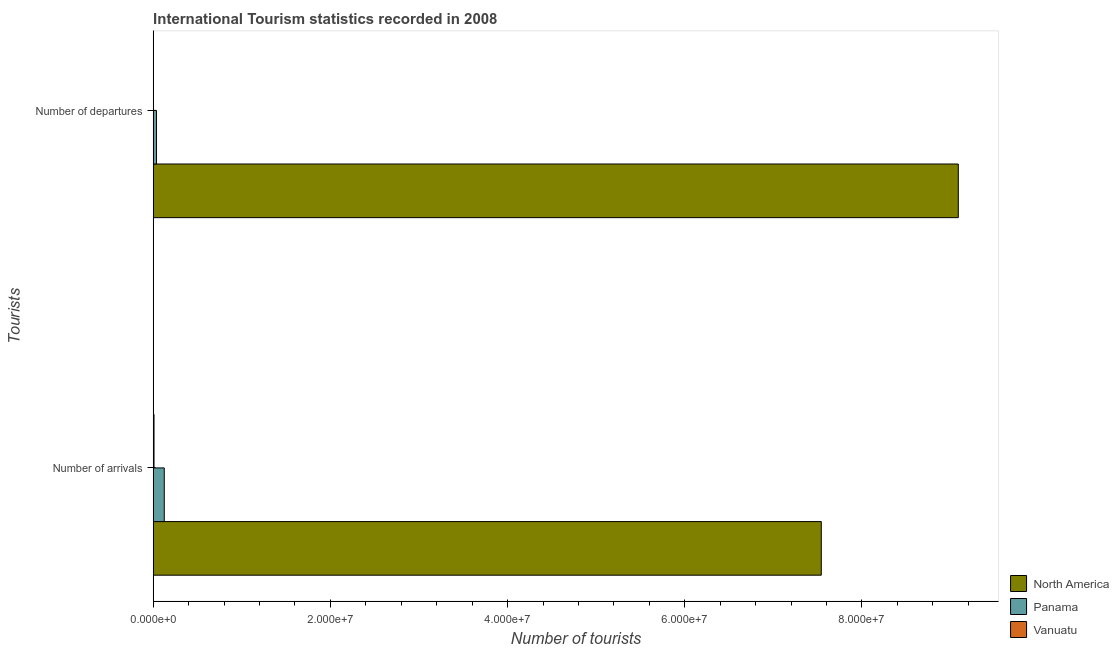How many groups of bars are there?
Offer a very short reply. 2. Are the number of bars per tick equal to the number of legend labels?
Offer a very short reply. Yes. What is the label of the 2nd group of bars from the top?
Give a very brief answer. Number of arrivals. What is the number of tourist departures in Vanuatu?
Make the answer very short. 1.90e+04. Across all countries, what is the maximum number of tourist arrivals?
Offer a terse response. 7.54e+07. Across all countries, what is the minimum number of tourist arrivals?
Your response must be concise. 9.10e+04. In which country was the number of tourist departures maximum?
Provide a short and direct response. North America. In which country was the number of tourist departures minimum?
Your answer should be very brief. Vanuatu. What is the total number of tourist arrivals in the graph?
Ensure brevity in your answer.  7.68e+07. What is the difference between the number of tourist departures in Panama and that in North America?
Your response must be concise. -9.05e+07. What is the difference between the number of tourist arrivals in Panama and the number of tourist departures in North America?
Ensure brevity in your answer.  -8.96e+07. What is the average number of tourist departures per country?
Your answer should be very brief. 3.04e+07. What is the difference between the number of tourist departures and number of tourist arrivals in Vanuatu?
Make the answer very short. -7.20e+04. In how many countries, is the number of tourist arrivals greater than 56000000 ?
Your answer should be compact. 1. What is the ratio of the number of tourist departures in North America to that in Panama?
Give a very brief answer. 246.28. In how many countries, is the number of tourist arrivals greater than the average number of tourist arrivals taken over all countries?
Provide a short and direct response. 1. What does the 3rd bar from the bottom in Number of departures represents?
Give a very brief answer. Vanuatu. How many bars are there?
Give a very brief answer. 6. Are all the bars in the graph horizontal?
Keep it short and to the point. Yes. How many countries are there in the graph?
Your answer should be compact. 3. Are the values on the major ticks of X-axis written in scientific E-notation?
Give a very brief answer. Yes. Does the graph contain grids?
Offer a very short reply. No. Where does the legend appear in the graph?
Provide a short and direct response. Bottom right. How many legend labels are there?
Make the answer very short. 3. How are the legend labels stacked?
Provide a succinct answer. Vertical. What is the title of the graph?
Provide a short and direct response. International Tourism statistics recorded in 2008. Does "Arab World" appear as one of the legend labels in the graph?
Provide a short and direct response. No. What is the label or title of the X-axis?
Offer a very short reply. Number of tourists. What is the label or title of the Y-axis?
Provide a succinct answer. Tourists. What is the Number of tourists in North America in Number of arrivals?
Offer a terse response. 7.54e+07. What is the Number of tourists of Panama in Number of arrivals?
Make the answer very short. 1.25e+06. What is the Number of tourists in Vanuatu in Number of arrivals?
Make the answer very short. 9.10e+04. What is the Number of tourists of North America in Number of departures?
Keep it short and to the point. 9.09e+07. What is the Number of tourists of Panama in Number of departures?
Make the answer very short. 3.69e+05. What is the Number of tourists of Vanuatu in Number of departures?
Give a very brief answer. 1.90e+04. Across all Tourists, what is the maximum Number of tourists in North America?
Offer a very short reply. 9.09e+07. Across all Tourists, what is the maximum Number of tourists of Panama?
Ensure brevity in your answer.  1.25e+06. Across all Tourists, what is the maximum Number of tourists of Vanuatu?
Ensure brevity in your answer.  9.10e+04. Across all Tourists, what is the minimum Number of tourists of North America?
Make the answer very short. 7.54e+07. Across all Tourists, what is the minimum Number of tourists of Panama?
Your answer should be very brief. 3.69e+05. Across all Tourists, what is the minimum Number of tourists of Vanuatu?
Your answer should be compact. 1.90e+04. What is the total Number of tourists of North America in the graph?
Your answer should be very brief. 1.66e+08. What is the total Number of tourists in Panama in the graph?
Provide a short and direct response. 1.62e+06. What is the total Number of tourists in Vanuatu in the graph?
Provide a short and direct response. 1.10e+05. What is the difference between the Number of tourists in North America in Number of arrivals and that in Number of departures?
Offer a terse response. -1.55e+07. What is the difference between the Number of tourists of Panama in Number of arrivals and that in Number of departures?
Offer a very short reply. 8.78e+05. What is the difference between the Number of tourists of Vanuatu in Number of arrivals and that in Number of departures?
Provide a succinct answer. 7.20e+04. What is the difference between the Number of tourists of North America in Number of arrivals and the Number of tourists of Panama in Number of departures?
Your answer should be very brief. 7.50e+07. What is the difference between the Number of tourists in North America in Number of arrivals and the Number of tourists in Vanuatu in Number of departures?
Your answer should be very brief. 7.54e+07. What is the difference between the Number of tourists in Panama in Number of arrivals and the Number of tourists in Vanuatu in Number of departures?
Offer a terse response. 1.23e+06. What is the average Number of tourists of North America per Tourists?
Your response must be concise. 8.31e+07. What is the average Number of tourists in Panama per Tourists?
Keep it short and to the point. 8.08e+05. What is the average Number of tourists of Vanuatu per Tourists?
Make the answer very short. 5.50e+04. What is the difference between the Number of tourists in North America and Number of tourists in Panama in Number of arrivals?
Give a very brief answer. 7.42e+07. What is the difference between the Number of tourists of North America and Number of tourists of Vanuatu in Number of arrivals?
Give a very brief answer. 7.53e+07. What is the difference between the Number of tourists of Panama and Number of tourists of Vanuatu in Number of arrivals?
Give a very brief answer. 1.16e+06. What is the difference between the Number of tourists of North America and Number of tourists of Panama in Number of departures?
Your answer should be very brief. 9.05e+07. What is the difference between the Number of tourists of North America and Number of tourists of Vanuatu in Number of departures?
Your answer should be compact. 9.09e+07. What is the difference between the Number of tourists of Panama and Number of tourists of Vanuatu in Number of departures?
Make the answer very short. 3.50e+05. What is the ratio of the Number of tourists in North America in Number of arrivals to that in Number of departures?
Offer a terse response. 0.83. What is the ratio of the Number of tourists of Panama in Number of arrivals to that in Number of departures?
Provide a short and direct response. 3.38. What is the ratio of the Number of tourists of Vanuatu in Number of arrivals to that in Number of departures?
Your response must be concise. 4.79. What is the difference between the highest and the second highest Number of tourists in North America?
Ensure brevity in your answer.  1.55e+07. What is the difference between the highest and the second highest Number of tourists in Panama?
Offer a terse response. 8.78e+05. What is the difference between the highest and the second highest Number of tourists of Vanuatu?
Offer a very short reply. 7.20e+04. What is the difference between the highest and the lowest Number of tourists in North America?
Provide a short and direct response. 1.55e+07. What is the difference between the highest and the lowest Number of tourists in Panama?
Ensure brevity in your answer.  8.78e+05. What is the difference between the highest and the lowest Number of tourists in Vanuatu?
Make the answer very short. 7.20e+04. 